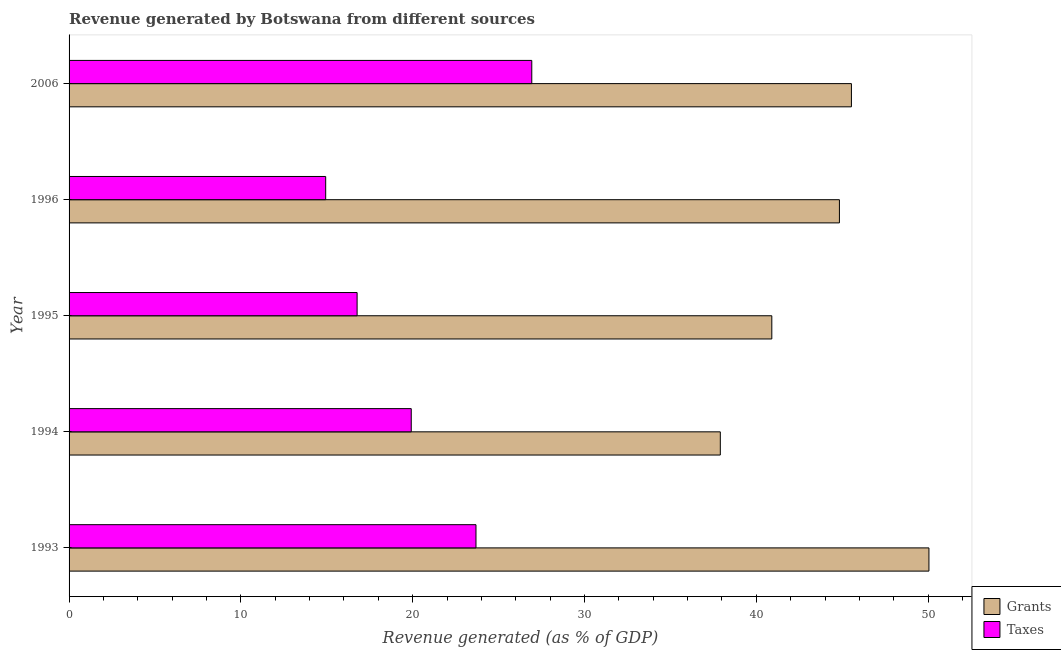Are the number of bars on each tick of the Y-axis equal?
Ensure brevity in your answer.  Yes. How many bars are there on the 5th tick from the top?
Offer a very short reply. 2. How many bars are there on the 4th tick from the bottom?
Your answer should be compact. 2. In how many cases, is the number of bars for a given year not equal to the number of legend labels?
Offer a terse response. 0. What is the revenue generated by taxes in 1993?
Ensure brevity in your answer.  23.68. Across all years, what is the maximum revenue generated by taxes?
Offer a terse response. 26.93. Across all years, what is the minimum revenue generated by taxes?
Offer a very short reply. 14.94. In which year was the revenue generated by taxes maximum?
Give a very brief answer. 2006. What is the total revenue generated by taxes in the graph?
Ensure brevity in your answer.  102.24. What is the difference between the revenue generated by taxes in 1993 and that in 1995?
Keep it short and to the point. 6.92. What is the difference between the revenue generated by taxes in 2006 and the revenue generated by grants in 1994?
Your answer should be compact. -10.97. What is the average revenue generated by taxes per year?
Provide a short and direct response. 20.45. In the year 2006, what is the difference between the revenue generated by grants and revenue generated by taxes?
Offer a terse response. 18.61. In how many years, is the revenue generated by grants greater than 42 %?
Give a very brief answer. 3. What is the ratio of the revenue generated by taxes in 1994 to that in 2006?
Your answer should be compact. 0.74. What is the difference between the highest and the second highest revenue generated by grants?
Your answer should be compact. 4.51. What is the difference between the highest and the lowest revenue generated by taxes?
Keep it short and to the point. 12. In how many years, is the revenue generated by taxes greater than the average revenue generated by taxes taken over all years?
Give a very brief answer. 2. Is the sum of the revenue generated by taxes in 1995 and 1996 greater than the maximum revenue generated by grants across all years?
Offer a very short reply. No. What does the 1st bar from the top in 1995 represents?
Make the answer very short. Taxes. What does the 2nd bar from the bottom in 2006 represents?
Provide a succinct answer. Taxes. Does the graph contain grids?
Make the answer very short. No. How many legend labels are there?
Your answer should be compact. 2. What is the title of the graph?
Keep it short and to the point. Revenue generated by Botswana from different sources. Does "Attending school" appear as one of the legend labels in the graph?
Ensure brevity in your answer.  No. What is the label or title of the X-axis?
Offer a terse response. Revenue generated (as % of GDP). What is the Revenue generated (as % of GDP) in Grants in 1993?
Keep it short and to the point. 50.05. What is the Revenue generated (as % of GDP) of Taxes in 1993?
Provide a short and direct response. 23.68. What is the Revenue generated (as % of GDP) in Grants in 1994?
Offer a terse response. 37.91. What is the Revenue generated (as % of GDP) of Taxes in 1994?
Make the answer very short. 19.92. What is the Revenue generated (as % of GDP) in Grants in 1995?
Provide a short and direct response. 40.9. What is the Revenue generated (as % of GDP) of Taxes in 1995?
Ensure brevity in your answer.  16.77. What is the Revenue generated (as % of GDP) in Grants in 1996?
Provide a succinct answer. 44.84. What is the Revenue generated (as % of GDP) of Taxes in 1996?
Give a very brief answer. 14.94. What is the Revenue generated (as % of GDP) of Grants in 2006?
Your answer should be compact. 45.54. What is the Revenue generated (as % of GDP) in Taxes in 2006?
Keep it short and to the point. 26.93. Across all years, what is the maximum Revenue generated (as % of GDP) of Grants?
Ensure brevity in your answer.  50.05. Across all years, what is the maximum Revenue generated (as % of GDP) in Taxes?
Keep it short and to the point. 26.93. Across all years, what is the minimum Revenue generated (as % of GDP) of Grants?
Your answer should be compact. 37.91. Across all years, what is the minimum Revenue generated (as % of GDP) of Taxes?
Ensure brevity in your answer.  14.94. What is the total Revenue generated (as % of GDP) in Grants in the graph?
Give a very brief answer. 219.24. What is the total Revenue generated (as % of GDP) of Taxes in the graph?
Make the answer very short. 102.24. What is the difference between the Revenue generated (as % of GDP) in Grants in 1993 and that in 1994?
Your answer should be very brief. 12.14. What is the difference between the Revenue generated (as % of GDP) in Taxes in 1993 and that in 1994?
Keep it short and to the point. 3.77. What is the difference between the Revenue generated (as % of GDP) of Grants in 1993 and that in 1995?
Keep it short and to the point. 9.15. What is the difference between the Revenue generated (as % of GDP) of Taxes in 1993 and that in 1995?
Make the answer very short. 6.92. What is the difference between the Revenue generated (as % of GDP) of Grants in 1993 and that in 1996?
Your answer should be very brief. 5.21. What is the difference between the Revenue generated (as % of GDP) in Taxes in 1993 and that in 1996?
Give a very brief answer. 8.75. What is the difference between the Revenue generated (as % of GDP) in Grants in 1993 and that in 2006?
Ensure brevity in your answer.  4.51. What is the difference between the Revenue generated (as % of GDP) in Taxes in 1993 and that in 2006?
Provide a succinct answer. -3.25. What is the difference between the Revenue generated (as % of GDP) in Grants in 1994 and that in 1995?
Ensure brevity in your answer.  -3. What is the difference between the Revenue generated (as % of GDP) of Taxes in 1994 and that in 1995?
Make the answer very short. 3.15. What is the difference between the Revenue generated (as % of GDP) of Grants in 1994 and that in 1996?
Your answer should be very brief. -6.93. What is the difference between the Revenue generated (as % of GDP) of Taxes in 1994 and that in 1996?
Offer a very short reply. 4.98. What is the difference between the Revenue generated (as % of GDP) in Grants in 1994 and that in 2006?
Your response must be concise. -7.63. What is the difference between the Revenue generated (as % of GDP) in Taxes in 1994 and that in 2006?
Your answer should be compact. -7.02. What is the difference between the Revenue generated (as % of GDP) of Grants in 1995 and that in 1996?
Provide a short and direct response. -3.94. What is the difference between the Revenue generated (as % of GDP) of Taxes in 1995 and that in 1996?
Keep it short and to the point. 1.83. What is the difference between the Revenue generated (as % of GDP) of Grants in 1995 and that in 2006?
Your answer should be very brief. -4.63. What is the difference between the Revenue generated (as % of GDP) in Taxes in 1995 and that in 2006?
Your answer should be very brief. -10.17. What is the difference between the Revenue generated (as % of GDP) of Grants in 1996 and that in 2006?
Make the answer very short. -0.7. What is the difference between the Revenue generated (as % of GDP) of Taxes in 1996 and that in 2006?
Offer a very short reply. -12. What is the difference between the Revenue generated (as % of GDP) of Grants in 1993 and the Revenue generated (as % of GDP) of Taxes in 1994?
Your answer should be very brief. 30.13. What is the difference between the Revenue generated (as % of GDP) of Grants in 1993 and the Revenue generated (as % of GDP) of Taxes in 1995?
Offer a terse response. 33.28. What is the difference between the Revenue generated (as % of GDP) of Grants in 1993 and the Revenue generated (as % of GDP) of Taxes in 1996?
Provide a short and direct response. 35.11. What is the difference between the Revenue generated (as % of GDP) in Grants in 1993 and the Revenue generated (as % of GDP) in Taxes in 2006?
Make the answer very short. 23.12. What is the difference between the Revenue generated (as % of GDP) of Grants in 1994 and the Revenue generated (as % of GDP) of Taxes in 1995?
Your answer should be compact. 21.14. What is the difference between the Revenue generated (as % of GDP) of Grants in 1994 and the Revenue generated (as % of GDP) of Taxes in 1996?
Make the answer very short. 22.97. What is the difference between the Revenue generated (as % of GDP) of Grants in 1994 and the Revenue generated (as % of GDP) of Taxes in 2006?
Your answer should be very brief. 10.97. What is the difference between the Revenue generated (as % of GDP) in Grants in 1995 and the Revenue generated (as % of GDP) in Taxes in 1996?
Your response must be concise. 25.97. What is the difference between the Revenue generated (as % of GDP) of Grants in 1995 and the Revenue generated (as % of GDP) of Taxes in 2006?
Provide a succinct answer. 13.97. What is the difference between the Revenue generated (as % of GDP) in Grants in 1996 and the Revenue generated (as % of GDP) in Taxes in 2006?
Offer a terse response. 17.91. What is the average Revenue generated (as % of GDP) in Grants per year?
Ensure brevity in your answer.  43.85. What is the average Revenue generated (as % of GDP) of Taxes per year?
Provide a succinct answer. 20.45. In the year 1993, what is the difference between the Revenue generated (as % of GDP) in Grants and Revenue generated (as % of GDP) in Taxes?
Make the answer very short. 26.37. In the year 1994, what is the difference between the Revenue generated (as % of GDP) in Grants and Revenue generated (as % of GDP) in Taxes?
Ensure brevity in your answer.  17.99. In the year 1995, what is the difference between the Revenue generated (as % of GDP) of Grants and Revenue generated (as % of GDP) of Taxes?
Offer a terse response. 24.14. In the year 1996, what is the difference between the Revenue generated (as % of GDP) of Grants and Revenue generated (as % of GDP) of Taxes?
Offer a terse response. 29.9. In the year 2006, what is the difference between the Revenue generated (as % of GDP) of Grants and Revenue generated (as % of GDP) of Taxes?
Your answer should be very brief. 18.61. What is the ratio of the Revenue generated (as % of GDP) of Grants in 1993 to that in 1994?
Provide a short and direct response. 1.32. What is the ratio of the Revenue generated (as % of GDP) of Taxes in 1993 to that in 1994?
Make the answer very short. 1.19. What is the ratio of the Revenue generated (as % of GDP) in Grants in 1993 to that in 1995?
Provide a short and direct response. 1.22. What is the ratio of the Revenue generated (as % of GDP) of Taxes in 1993 to that in 1995?
Your response must be concise. 1.41. What is the ratio of the Revenue generated (as % of GDP) of Grants in 1993 to that in 1996?
Your answer should be very brief. 1.12. What is the ratio of the Revenue generated (as % of GDP) of Taxes in 1993 to that in 1996?
Offer a terse response. 1.59. What is the ratio of the Revenue generated (as % of GDP) of Grants in 1993 to that in 2006?
Ensure brevity in your answer.  1.1. What is the ratio of the Revenue generated (as % of GDP) in Taxes in 1993 to that in 2006?
Your answer should be very brief. 0.88. What is the ratio of the Revenue generated (as % of GDP) of Grants in 1994 to that in 1995?
Keep it short and to the point. 0.93. What is the ratio of the Revenue generated (as % of GDP) of Taxes in 1994 to that in 1995?
Your answer should be compact. 1.19. What is the ratio of the Revenue generated (as % of GDP) in Grants in 1994 to that in 1996?
Provide a succinct answer. 0.85. What is the ratio of the Revenue generated (as % of GDP) of Taxes in 1994 to that in 1996?
Keep it short and to the point. 1.33. What is the ratio of the Revenue generated (as % of GDP) in Grants in 1994 to that in 2006?
Your answer should be compact. 0.83. What is the ratio of the Revenue generated (as % of GDP) in Taxes in 1994 to that in 2006?
Your answer should be very brief. 0.74. What is the ratio of the Revenue generated (as % of GDP) of Grants in 1995 to that in 1996?
Ensure brevity in your answer.  0.91. What is the ratio of the Revenue generated (as % of GDP) of Taxes in 1995 to that in 1996?
Your answer should be compact. 1.12. What is the ratio of the Revenue generated (as % of GDP) in Grants in 1995 to that in 2006?
Provide a short and direct response. 0.9. What is the ratio of the Revenue generated (as % of GDP) in Taxes in 1995 to that in 2006?
Provide a succinct answer. 0.62. What is the ratio of the Revenue generated (as % of GDP) of Grants in 1996 to that in 2006?
Your answer should be compact. 0.98. What is the ratio of the Revenue generated (as % of GDP) of Taxes in 1996 to that in 2006?
Keep it short and to the point. 0.55. What is the difference between the highest and the second highest Revenue generated (as % of GDP) in Grants?
Provide a short and direct response. 4.51. What is the difference between the highest and the second highest Revenue generated (as % of GDP) in Taxes?
Ensure brevity in your answer.  3.25. What is the difference between the highest and the lowest Revenue generated (as % of GDP) of Grants?
Give a very brief answer. 12.14. What is the difference between the highest and the lowest Revenue generated (as % of GDP) in Taxes?
Provide a short and direct response. 12. 